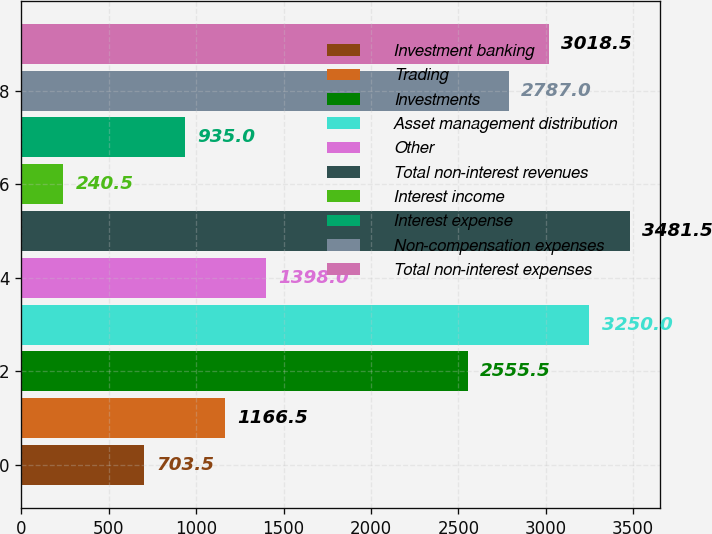Convert chart to OTSL. <chart><loc_0><loc_0><loc_500><loc_500><bar_chart><fcel>Investment banking<fcel>Trading<fcel>Investments<fcel>Asset management distribution<fcel>Other<fcel>Total non-interest revenues<fcel>Interest income<fcel>Interest expense<fcel>Non-compensation expenses<fcel>Total non-interest expenses<nl><fcel>703.5<fcel>1166.5<fcel>2555.5<fcel>3250<fcel>1398<fcel>3481.5<fcel>240.5<fcel>935<fcel>2787<fcel>3018.5<nl></chart> 